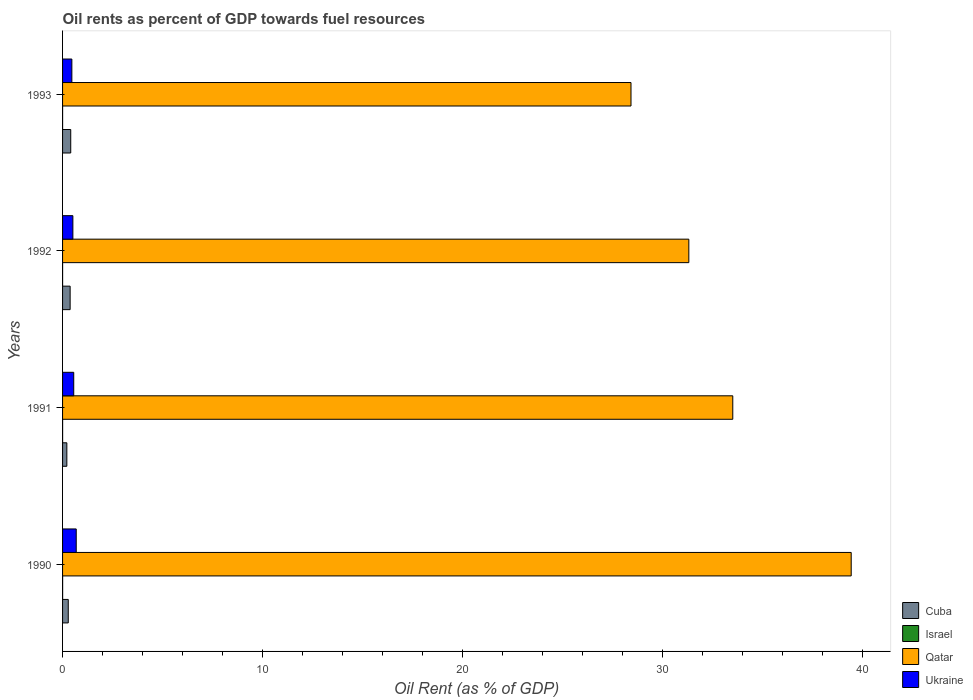How many different coloured bars are there?
Provide a succinct answer. 4. Are the number of bars per tick equal to the number of legend labels?
Your answer should be compact. Yes. Are the number of bars on each tick of the Y-axis equal?
Give a very brief answer. Yes. How many bars are there on the 3rd tick from the top?
Provide a short and direct response. 4. What is the label of the 1st group of bars from the top?
Offer a terse response. 1993. What is the oil rent in Cuba in 1993?
Give a very brief answer. 0.41. Across all years, what is the maximum oil rent in Cuba?
Provide a succinct answer. 0.41. Across all years, what is the minimum oil rent in Israel?
Your response must be concise. 0. In which year was the oil rent in Cuba maximum?
Ensure brevity in your answer.  1993. In which year was the oil rent in Cuba minimum?
Keep it short and to the point. 1991. What is the total oil rent in Ukraine in the graph?
Provide a succinct answer. 2.22. What is the difference between the oil rent in Qatar in 1991 and that in 1992?
Provide a succinct answer. 2.2. What is the difference between the oil rent in Qatar in 1990 and the oil rent in Cuba in 1993?
Give a very brief answer. 39.01. What is the average oil rent in Ukraine per year?
Keep it short and to the point. 0.56. In the year 1992, what is the difference between the oil rent in Cuba and oil rent in Israel?
Give a very brief answer. 0.38. What is the ratio of the oil rent in Ukraine in 1991 to that in 1993?
Ensure brevity in your answer.  1.2. What is the difference between the highest and the second highest oil rent in Ukraine?
Ensure brevity in your answer.  0.12. What is the difference between the highest and the lowest oil rent in Ukraine?
Ensure brevity in your answer.  0.22. Is the sum of the oil rent in Israel in 1990 and 1991 greater than the maximum oil rent in Ukraine across all years?
Give a very brief answer. No. Is it the case that in every year, the sum of the oil rent in Ukraine and oil rent in Cuba is greater than the sum of oil rent in Israel and oil rent in Qatar?
Give a very brief answer. Yes. What does the 3rd bar from the top in 1990 represents?
Provide a short and direct response. Israel. What does the 1st bar from the bottom in 1992 represents?
Offer a very short reply. Cuba. Is it the case that in every year, the sum of the oil rent in Qatar and oil rent in Cuba is greater than the oil rent in Ukraine?
Provide a short and direct response. Yes. How many bars are there?
Offer a terse response. 16. Are all the bars in the graph horizontal?
Your answer should be compact. Yes. How many years are there in the graph?
Ensure brevity in your answer.  4. What is the difference between two consecutive major ticks on the X-axis?
Ensure brevity in your answer.  10. Does the graph contain any zero values?
Ensure brevity in your answer.  No. Where does the legend appear in the graph?
Provide a succinct answer. Bottom right. How many legend labels are there?
Your answer should be very brief. 4. How are the legend labels stacked?
Your answer should be very brief. Vertical. What is the title of the graph?
Provide a succinct answer. Oil rents as percent of GDP towards fuel resources. What is the label or title of the X-axis?
Offer a very short reply. Oil Rent (as % of GDP). What is the label or title of the Y-axis?
Provide a short and direct response. Years. What is the Oil Rent (as % of GDP) in Cuba in 1990?
Keep it short and to the point. 0.29. What is the Oil Rent (as % of GDP) in Israel in 1990?
Provide a short and direct response. 0. What is the Oil Rent (as % of GDP) of Qatar in 1990?
Make the answer very short. 39.42. What is the Oil Rent (as % of GDP) in Ukraine in 1990?
Your answer should be very brief. 0.68. What is the Oil Rent (as % of GDP) in Cuba in 1991?
Provide a succinct answer. 0.21. What is the Oil Rent (as % of GDP) of Israel in 1991?
Offer a very short reply. 0. What is the Oil Rent (as % of GDP) of Qatar in 1991?
Ensure brevity in your answer.  33.5. What is the Oil Rent (as % of GDP) in Ukraine in 1991?
Ensure brevity in your answer.  0.56. What is the Oil Rent (as % of GDP) of Cuba in 1992?
Make the answer very short. 0.38. What is the Oil Rent (as % of GDP) in Israel in 1992?
Provide a succinct answer. 0. What is the Oil Rent (as % of GDP) of Qatar in 1992?
Provide a succinct answer. 31.3. What is the Oil Rent (as % of GDP) in Ukraine in 1992?
Ensure brevity in your answer.  0.52. What is the Oil Rent (as % of GDP) in Cuba in 1993?
Provide a succinct answer. 0.41. What is the Oil Rent (as % of GDP) in Israel in 1993?
Provide a short and direct response. 0. What is the Oil Rent (as % of GDP) in Qatar in 1993?
Your response must be concise. 28.41. What is the Oil Rent (as % of GDP) in Ukraine in 1993?
Provide a succinct answer. 0.46. Across all years, what is the maximum Oil Rent (as % of GDP) of Cuba?
Provide a short and direct response. 0.41. Across all years, what is the maximum Oil Rent (as % of GDP) of Israel?
Keep it short and to the point. 0. Across all years, what is the maximum Oil Rent (as % of GDP) in Qatar?
Keep it short and to the point. 39.42. Across all years, what is the maximum Oil Rent (as % of GDP) of Ukraine?
Give a very brief answer. 0.68. Across all years, what is the minimum Oil Rent (as % of GDP) in Cuba?
Offer a terse response. 0.21. Across all years, what is the minimum Oil Rent (as % of GDP) in Israel?
Your answer should be very brief. 0. Across all years, what is the minimum Oil Rent (as % of GDP) in Qatar?
Give a very brief answer. 28.41. Across all years, what is the minimum Oil Rent (as % of GDP) of Ukraine?
Make the answer very short. 0.46. What is the total Oil Rent (as % of GDP) of Israel in the graph?
Make the answer very short. 0.01. What is the total Oil Rent (as % of GDP) of Qatar in the graph?
Keep it short and to the point. 132.63. What is the total Oil Rent (as % of GDP) of Ukraine in the graph?
Ensure brevity in your answer.  2.22. What is the difference between the Oil Rent (as % of GDP) of Cuba in 1990 and that in 1991?
Give a very brief answer. 0.07. What is the difference between the Oil Rent (as % of GDP) of Israel in 1990 and that in 1991?
Your response must be concise. 0. What is the difference between the Oil Rent (as % of GDP) in Qatar in 1990 and that in 1991?
Provide a succinct answer. 5.92. What is the difference between the Oil Rent (as % of GDP) in Ukraine in 1990 and that in 1991?
Provide a short and direct response. 0.12. What is the difference between the Oil Rent (as % of GDP) in Cuba in 1990 and that in 1992?
Offer a terse response. -0.09. What is the difference between the Oil Rent (as % of GDP) in Israel in 1990 and that in 1992?
Offer a terse response. 0. What is the difference between the Oil Rent (as % of GDP) in Qatar in 1990 and that in 1992?
Your answer should be very brief. 8.12. What is the difference between the Oil Rent (as % of GDP) in Ukraine in 1990 and that in 1992?
Offer a very short reply. 0.17. What is the difference between the Oil Rent (as % of GDP) in Cuba in 1990 and that in 1993?
Ensure brevity in your answer.  -0.12. What is the difference between the Oil Rent (as % of GDP) in Israel in 1990 and that in 1993?
Give a very brief answer. 0. What is the difference between the Oil Rent (as % of GDP) in Qatar in 1990 and that in 1993?
Ensure brevity in your answer.  11.01. What is the difference between the Oil Rent (as % of GDP) of Ukraine in 1990 and that in 1993?
Make the answer very short. 0.22. What is the difference between the Oil Rent (as % of GDP) of Cuba in 1991 and that in 1992?
Offer a very short reply. -0.17. What is the difference between the Oil Rent (as % of GDP) in Qatar in 1991 and that in 1992?
Keep it short and to the point. 2.2. What is the difference between the Oil Rent (as % of GDP) of Ukraine in 1991 and that in 1992?
Keep it short and to the point. 0.04. What is the difference between the Oil Rent (as % of GDP) in Cuba in 1991 and that in 1993?
Keep it short and to the point. -0.19. What is the difference between the Oil Rent (as % of GDP) in Israel in 1991 and that in 1993?
Keep it short and to the point. 0. What is the difference between the Oil Rent (as % of GDP) in Qatar in 1991 and that in 1993?
Provide a short and direct response. 5.09. What is the difference between the Oil Rent (as % of GDP) in Ukraine in 1991 and that in 1993?
Make the answer very short. 0.09. What is the difference between the Oil Rent (as % of GDP) of Cuba in 1992 and that in 1993?
Your response must be concise. -0.03. What is the difference between the Oil Rent (as % of GDP) in Qatar in 1992 and that in 1993?
Provide a short and direct response. 2.89. What is the difference between the Oil Rent (as % of GDP) in Ukraine in 1992 and that in 1993?
Your answer should be compact. 0.05. What is the difference between the Oil Rent (as % of GDP) of Cuba in 1990 and the Oil Rent (as % of GDP) of Israel in 1991?
Offer a very short reply. 0.28. What is the difference between the Oil Rent (as % of GDP) in Cuba in 1990 and the Oil Rent (as % of GDP) in Qatar in 1991?
Give a very brief answer. -33.21. What is the difference between the Oil Rent (as % of GDP) of Cuba in 1990 and the Oil Rent (as % of GDP) of Ukraine in 1991?
Offer a terse response. -0.27. What is the difference between the Oil Rent (as % of GDP) of Israel in 1990 and the Oil Rent (as % of GDP) of Qatar in 1991?
Ensure brevity in your answer.  -33.5. What is the difference between the Oil Rent (as % of GDP) in Israel in 1990 and the Oil Rent (as % of GDP) in Ukraine in 1991?
Offer a very short reply. -0.56. What is the difference between the Oil Rent (as % of GDP) of Qatar in 1990 and the Oil Rent (as % of GDP) of Ukraine in 1991?
Give a very brief answer. 38.86. What is the difference between the Oil Rent (as % of GDP) in Cuba in 1990 and the Oil Rent (as % of GDP) in Israel in 1992?
Keep it short and to the point. 0.28. What is the difference between the Oil Rent (as % of GDP) in Cuba in 1990 and the Oil Rent (as % of GDP) in Qatar in 1992?
Provide a short and direct response. -31.02. What is the difference between the Oil Rent (as % of GDP) of Cuba in 1990 and the Oil Rent (as % of GDP) of Ukraine in 1992?
Provide a succinct answer. -0.23. What is the difference between the Oil Rent (as % of GDP) in Israel in 1990 and the Oil Rent (as % of GDP) in Qatar in 1992?
Your answer should be very brief. -31.3. What is the difference between the Oil Rent (as % of GDP) of Israel in 1990 and the Oil Rent (as % of GDP) of Ukraine in 1992?
Offer a very short reply. -0.51. What is the difference between the Oil Rent (as % of GDP) of Qatar in 1990 and the Oil Rent (as % of GDP) of Ukraine in 1992?
Give a very brief answer. 38.9. What is the difference between the Oil Rent (as % of GDP) of Cuba in 1990 and the Oil Rent (as % of GDP) of Israel in 1993?
Make the answer very short. 0.28. What is the difference between the Oil Rent (as % of GDP) of Cuba in 1990 and the Oil Rent (as % of GDP) of Qatar in 1993?
Your answer should be very brief. -28.13. What is the difference between the Oil Rent (as % of GDP) in Cuba in 1990 and the Oil Rent (as % of GDP) in Ukraine in 1993?
Your answer should be compact. -0.18. What is the difference between the Oil Rent (as % of GDP) of Israel in 1990 and the Oil Rent (as % of GDP) of Qatar in 1993?
Give a very brief answer. -28.41. What is the difference between the Oil Rent (as % of GDP) of Israel in 1990 and the Oil Rent (as % of GDP) of Ukraine in 1993?
Provide a succinct answer. -0.46. What is the difference between the Oil Rent (as % of GDP) of Qatar in 1990 and the Oil Rent (as % of GDP) of Ukraine in 1993?
Offer a terse response. 38.95. What is the difference between the Oil Rent (as % of GDP) in Cuba in 1991 and the Oil Rent (as % of GDP) in Israel in 1992?
Offer a very short reply. 0.21. What is the difference between the Oil Rent (as % of GDP) in Cuba in 1991 and the Oil Rent (as % of GDP) in Qatar in 1992?
Your answer should be compact. -31.09. What is the difference between the Oil Rent (as % of GDP) in Cuba in 1991 and the Oil Rent (as % of GDP) in Ukraine in 1992?
Your response must be concise. -0.3. What is the difference between the Oil Rent (as % of GDP) of Israel in 1991 and the Oil Rent (as % of GDP) of Qatar in 1992?
Keep it short and to the point. -31.3. What is the difference between the Oil Rent (as % of GDP) in Israel in 1991 and the Oil Rent (as % of GDP) in Ukraine in 1992?
Offer a very short reply. -0.51. What is the difference between the Oil Rent (as % of GDP) in Qatar in 1991 and the Oil Rent (as % of GDP) in Ukraine in 1992?
Give a very brief answer. 32.98. What is the difference between the Oil Rent (as % of GDP) in Cuba in 1991 and the Oil Rent (as % of GDP) in Israel in 1993?
Make the answer very short. 0.21. What is the difference between the Oil Rent (as % of GDP) of Cuba in 1991 and the Oil Rent (as % of GDP) of Qatar in 1993?
Offer a very short reply. -28.2. What is the difference between the Oil Rent (as % of GDP) of Cuba in 1991 and the Oil Rent (as % of GDP) of Ukraine in 1993?
Ensure brevity in your answer.  -0.25. What is the difference between the Oil Rent (as % of GDP) of Israel in 1991 and the Oil Rent (as % of GDP) of Qatar in 1993?
Provide a succinct answer. -28.41. What is the difference between the Oil Rent (as % of GDP) of Israel in 1991 and the Oil Rent (as % of GDP) of Ukraine in 1993?
Your answer should be compact. -0.46. What is the difference between the Oil Rent (as % of GDP) of Qatar in 1991 and the Oil Rent (as % of GDP) of Ukraine in 1993?
Make the answer very short. 33.03. What is the difference between the Oil Rent (as % of GDP) of Cuba in 1992 and the Oil Rent (as % of GDP) of Israel in 1993?
Make the answer very short. 0.38. What is the difference between the Oil Rent (as % of GDP) in Cuba in 1992 and the Oil Rent (as % of GDP) in Qatar in 1993?
Offer a very short reply. -28.03. What is the difference between the Oil Rent (as % of GDP) in Cuba in 1992 and the Oil Rent (as % of GDP) in Ukraine in 1993?
Keep it short and to the point. -0.09. What is the difference between the Oil Rent (as % of GDP) in Israel in 1992 and the Oil Rent (as % of GDP) in Qatar in 1993?
Provide a succinct answer. -28.41. What is the difference between the Oil Rent (as % of GDP) in Israel in 1992 and the Oil Rent (as % of GDP) in Ukraine in 1993?
Provide a short and direct response. -0.46. What is the difference between the Oil Rent (as % of GDP) in Qatar in 1992 and the Oil Rent (as % of GDP) in Ukraine in 1993?
Give a very brief answer. 30.84. What is the average Oil Rent (as % of GDP) in Cuba per year?
Provide a succinct answer. 0.32. What is the average Oil Rent (as % of GDP) in Israel per year?
Provide a short and direct response. 0. What is the average Oil Rent (as % of GDP) in Qatar per year?
Provide a succinct answer. 33.16. What is the average Oil Rent (as % of GDP) of Ukraine per year?
Ensure brevity in your answer.  0.56. In the year 1990, what is the difference between the Oil Rent (as % of GDP) of Cuba and Oil Rent (as % of GDP) of Israel?
Your answer should be very brief. 0.28. In the year 1990, what is the difference between the Oil Rent (as % of GDP) in Cuba and Oil Rent (as % of GDP) in Qatar?
Keep it short and to the point. -39.13. In the year 1990, what is the difference between the Oil Rent (as % of GDP) in Cuba and Oil Rent (as % of GDP) in Ukraine?
Your answer should be very brief. -0.4. In the year 1990, what is the difference between the Oil Rent (as % of GDP) of Israel and Oil Rent (as % of GDP) of Qatar?
Your response must be concise. -39.42. In the year 1990, what is the difference between the Oil Rent (as % of GDP) in Israel and Oil Rent (as % of GDP) in Ukraine?
Keep it short and to the point. -0.68. In the year 1990, what is the difference between the Oil Rent (as % of GDP) in Qatar and Oil Rent (as % of GDP) in Ukraine?
Keep it short and to the point. 38.74. In the year 1991, what is the difference between the Oil Rent (as % of GDP) of Cuba and Oil Rent (as % of GDP) of Israel?
Your response must be concise. 0.21. In the year 1991, what is the difference between the Oil Rent (as % of GDP) of Cuba and Oil Rent (as % of GDP) of Qatar?
Offer a very short reply. -33.29. In the year 1991, what is the difference between the Oil Rent (as % of GDP) of Cuba and Oil Rent (as % of GDP) of Ukraine?
Offer a terse response. -0.34. In the year 1991, what is the difference between the Oil Rent (as % of GDP) of Israel and Oil Rent (as % of GDP) of Qatar?
Offer a very short reply. -33.5. In the year 1991, what is the difference between the Oil Rent (as % of GDP) of Israel and Oil Rent (as % of GDP) of Ukraine?
Offer a terse response. -0.56. In the year 1991, what is the difference between the Oil Rent (as % of GDP) of Qatar and Oil Rent (as % of GDP) of Ukraine?
Provide a succinct answer. 32.94. In the year 1992, what is the difference between the Oil Rent (as % of GDP) of Cuba and Oil Rent (as % of GDP) of Israel?
Offer a very short reply. 0.38. In the year 1992, what is the difference between the Oil Rent (as % of GDP) in Cuba and Oil Rent (as % of GDP) in Qatar?
Keep it short and to the point. -30.92. In the year 1992, what is the difference between the Oil Rent (as % of GDP) of Cuba and Oil Rent (as % of GDP) of Ukraine?
Make the answer very short. -0.14. In the year 1992, what is the difference between the Oil Rent (as % of GDP) of Israel and Oil Rent (as % of GDP) of Qatar?
Give a very brief answer. -31.3. In the year 1992, what is the difference between the Oil Rent (as % of GDP) in Israel and Oil Rent (as % of GDP) in Ukraine?
Ensure brevity in your answer.  -0.51. In the year 1992, what is the difference between the Oil Rent (as % of GDP) of Qatar and Oil Rent (as % of GDP) of Ukraine?
Provide a succinct answer. 30.79. In the year 1993, what is the difference between the Oil Rent (as % of GDP) in Cuba and Oil Rent (as % of GDP) in Israel?
Ensure brevity in your answer.  0.41. In the year 1993, what is the difference between the Oil Rent (as % of GDP) in Cuba and Oil Rent (as % of GDP) in Qatar?
Ensure brevity in your answer.  -28. In the year 1993, what is the difference between the Oil Rent (as % of GDP) in Cuba and Oil Rent (as % of GDP) in Ukraine?
Provide a succinct answer. -0.06. In the year 1993, what is the difference between the Oil Rent (as % of GDP) of Israel and Oil Rent (as % of GDP) of Qatar?
Make the answer very short. -28.41. In the year 1993, what is the difference between the Oil Rent (as % of GDP) in Israel and Oil Rent (as % of GDP) in Ukraine?
Provide a succinct answer. -0.46. In the year 1993, what is the difference between the Oil Rent (as % of GDP) in Qatar and Oil Rent (as % of GDP) in Ukraine?
Ensure brevity in your answer.  27.95. What is the ratio of the Oil Rent (as % of GDP) in Cuba in 1990 to that in 1991?
Give a very brief answer. 1.34. What is the ratio of the Oil Rent (as % of GDP) of Israel in 1990 to that in 1991?
Your answer should be very brief. 1.38. What is the ratio of the Oil Rent (as % of GDP) in Qatar in 1990 to that in 1991?
Make the answer very short. 1.18. What is the ratio of the Oil Rent (as % of GDP) of Ukraine in 1990 to that in 1991?
Make the answer very short. 1.22. What is the ratio of the Oil Rent (as % of GDP) in Cuba in 1990 to that in 1992?
Your response must be concise. 0.75. What is the ratio of the Oil Rent (as % of GDP) in Israel in 1990 to that in 1992?
Provide a succinct answer. 1.7. What is the ratio of the Oil Rent (as % of GDP) in Qatar in 1990 to that in 1992?
Your response must be concise. 1.26. What is the ratio of the Oil Rent (as % of GDP) of Ukraine in 1990 to that in 1992?
Keep it short and to the point. 1.33. What is the ratio of the Oil Rent (as % of GDP) of Cuba in 1990 to that in 1993?
Keep it short and to the point. 0.7. What is the ratio of the Oil Rent (as % of GDP) of Israel in 1990 to that in 1993?
Provide a short and direct response. 2.38. What is the ratio of the Oil Rent (as % of GDP) in Qatar in 1990 to that in 1993?
Ensure brevity in your answer.  1.39. What is the ratio of the Oil Rent (as % of GDP) in Ukraine in 1990 to that in 1993?
Keep it short and to the point. 1.47. What is the ratio of the Oil Rent (as % of GDP) of Cuba in 1991 to that in 1992?
Ensure brevity in your answer.  0.56. What is the ratio of the Oil Rent (as % of GDP) of Israel in 1991 to that in 1992?
Give a very brief answer. 1.23. What is the ratio of the Oil Rent (as % of GDP) of Qatar in 1991 to that in 1992?
Ensure brevity in your answer.  1.07. What is the ratio of the Oil Rent (as % of GDP) in Ukraine in 1991 to that in 1992?
Provide a short and direct response. 1.08. What is the ratio of the Oil Rent (as % of GDP) in Cuba in 1991 to that in 1993?
Offer a very short reply. 0.52. What is the ratio of the Oil Rent (as % of GDP) in Israel in 1991 to that in 1993?
Make the answer very short. 1.73. What is the ratio of the Oil Rent (as % of GDP) of Qatar in 1991 to that in 1993?
Provide a short and direct response. 1.18. What is the ratio of the Oil Rent (as % of GDP) in Ukraine in 1991 to that in 1993?
Your answer should be compact. 1.2. What is the ratio of the Oil Rent (as % of GDP) in Cuba in 1992 to that in 1993?
Your answer should be compact. 0.93. What is the ratio of the Oil Rent (as % of GDP) in Israel in 1992 to that in 1993?
Offer a terse response. 1.4. What is the ratio of the Oil Rent (as % of GDP) in Qatar in 1992 to that in 1993?
Provide a short and direct response. 1.1. What is the ratio of the Oil Rent (as % of GDP) of Ukraine in 1992 to that in 1993?
Make the answer very short. 1.11. What is the difference between the highest and the second highest Oil Rent (as % of GDP) in Cuba?
Your answer should be very brief. 0.03. What is the difference between the highest and the second highest Oil Rent (as % of GDP) of Israel?
Give a very brief answer. 0. What is the difference between the highest and the second highest Oil Rent (as % of GDP) of Qatar?
Your response must be concise. 5.92. What is the difference between the highest and the second highest Oil Rent (as % of GDP) of Ukraine?
Your response must be concise. 0.12. What is the difference between the highest and the lowest Oil Rent (as % of GDP) in Cuba?
Your response must be concise. 0.19. What is the difference between the highest and the lowest Oil Rent (as % of GDP) in Israel?
Your answer should be very brief. 0. What is the difference between the highest and the lowest Oil Rent (as % of GDP) of Qatar?
Provide a succinct answer. 11.01. What is the difference between the highest and the lowest Oil Rent (as % of GDP) in Ukraine?
Provide a succinct answer. 0.22. 